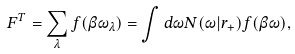Convert formula to latex. <formula><loc_0><loc_0><loc_500><loc_500>F ^ { T } = \sum _ { \lambda } { f ( \beta \omega _ { \lambda } } ) = \int { d \omega N ( \omega | r _ { + } ) } f ( \beta \omega ) ,</formula> 